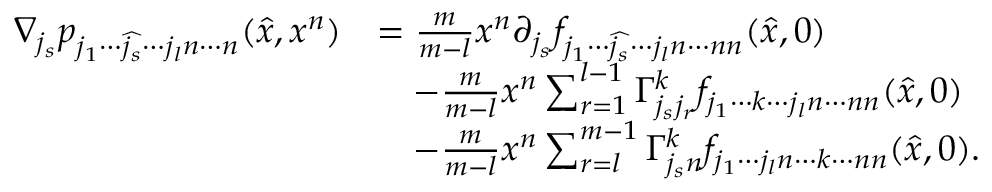<formula> <loc_0><loc_0><loc_500><loc_500>\begin{array} { r l } { \nabla _ { j _ { s } } p _ { j _ { 1 } \cdots \widehat { j _ { s } } \cdots j _ { l } n \cdots n } ( \hat { x } , x ^ { n } ) } & { = \frac { m } { m - l } x ^ { n } \partial _ { j _ { s } } f _ { j _ { 1 } \cdots \widehat { j _ { s } } \cdots j _ { l } n \cdots n n } ( \hat { x } , 0 ) } \\ & { \quad - \frac { m } { m - l } x ^ { n } \sum _ { r = 1 } ^ { l - 1 } \Gamma _ { j _ { s } j _ { r } } ^ { k } f _ { j _ { 1 } \cdots k \cdots j _ { l } n \cdots n n } ( \hat { x } , 0 ) } \\ & { \quad - \frac { m } { m - l } x ^ { n } \sum _ { r = l } ^ { m - 1 } \Gamma _ { j _ { s } n } ^ { k } f _ { j _ { 1 } \cdots j _ { l } n \cdots k \cdots n n } ( \hat { x } , 0 ) . } \end{array}</formula> 